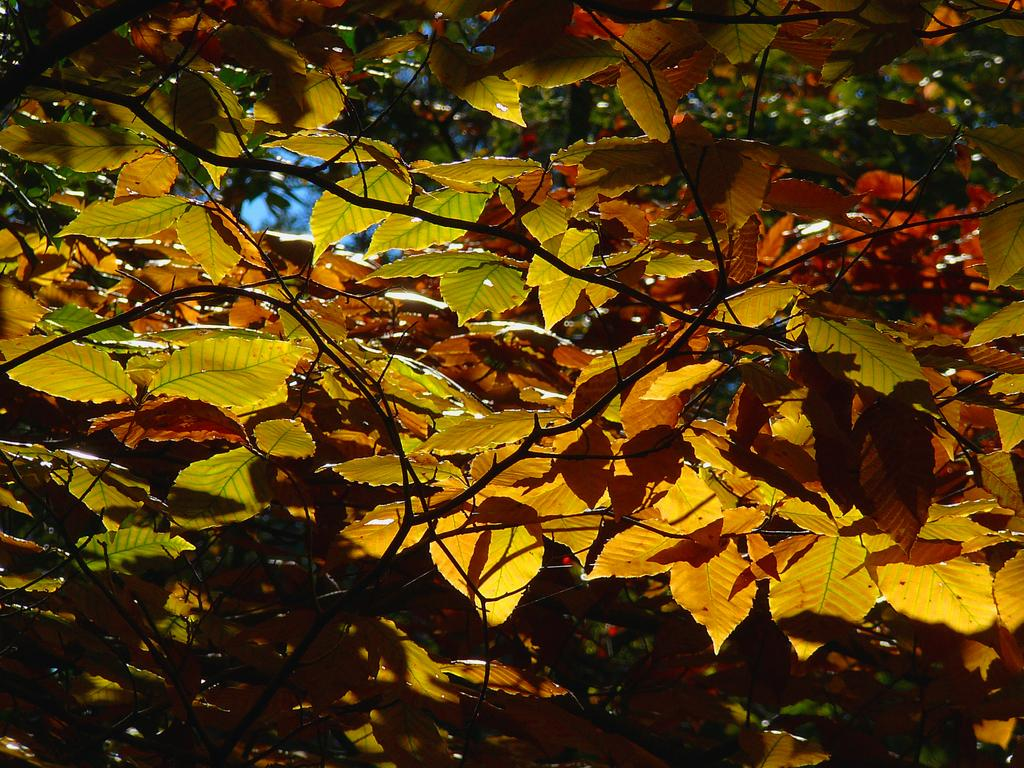What type of vegetation can be seen in the image? There are leaves of a tree in the image. What part of the natural environment is visible in the image? The sky is visible in the image. What type of soap is being used to clean the leaves in the image? There is no soap or cleaning activity present in the image; it simply shows leaves of a tree and the sky. 